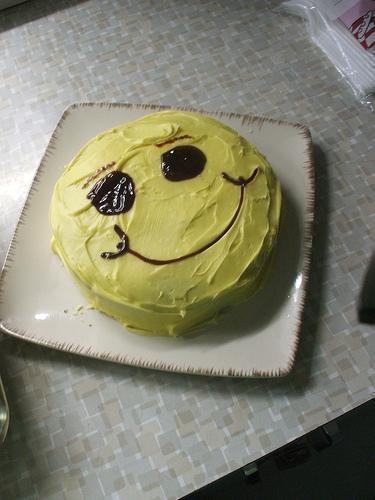How many eyes are there are the cake?
Give a very brief answer. 2. 